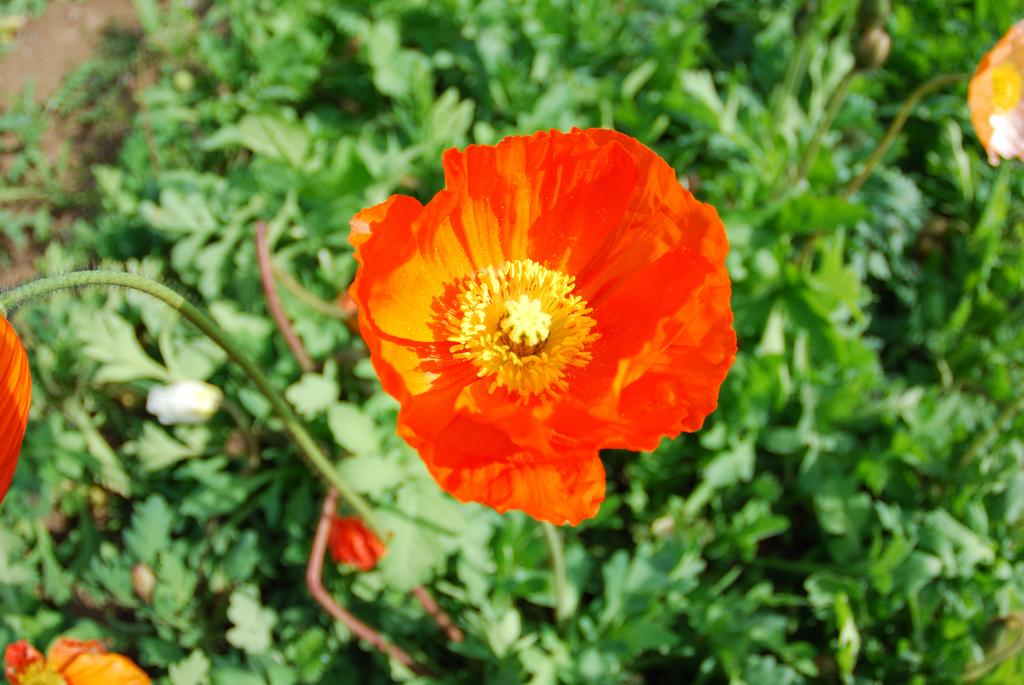What type of flora can be seen in the image? There are flowers in the image. What color are the flowers? The flowers are red in color. What else can be seen in the background of the image? There are plants visible in the background of the image. How many nails can be seen holding the flowers in the image? There are no nails present in the image; the flowers are not attached to anything. 